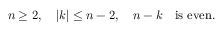Convert formula to latex. <formula><loc_0><loc_0><loc_500><loc_500>n \geq 2 , \quad | k | \leq n - 2 , \quad n - k \quad i s e v e n .</formula> 